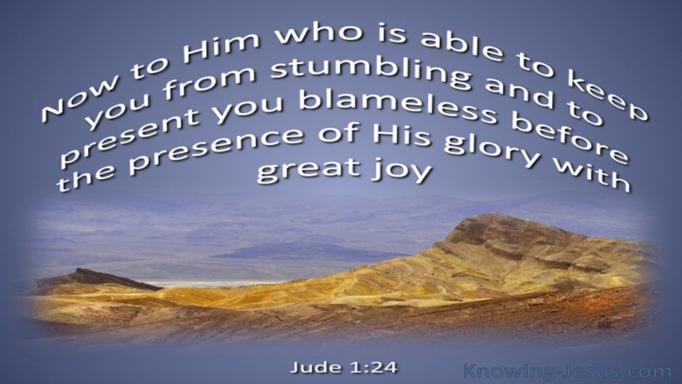How does 'joy' play a role in the message of Jude 1:24, considering the landscape shown? In Jude 1:24, the mention of 'great joy' in combination with the stark landscape might symbolize the profound joy that comes from God's salvation, contrasting with the often arid and challenging journey of faith. This joy is not dependent on external circumstances but is a deep, enduring state granted by God's presence and His promise to sustain and redeem. 